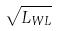<formula> <loc_0><loc_0><loc_500><loc_500>\sqrt { L _ { W L } }</formula> 